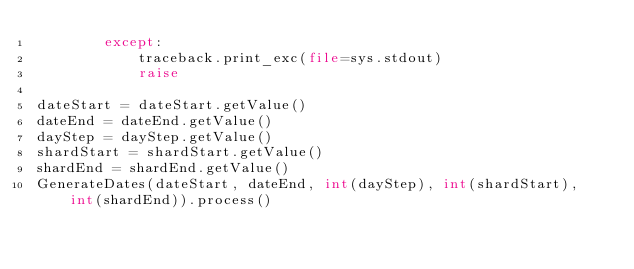Convert code to text. <code><loc_0><loc_0><loc_500><loc_500><_Python_>        except:
            traceback.print_exc(file=sys.stdout)
            raise

dateStart = dateStart.getValue()
dateEnd = dateEnd.getValue()
dayStep = dayStep.getValue()
shardStart = shardStart.getValue()
shardEnd = shardEnd.getValue()
GenerateDates(dateStart, dateEnd, int(dayStep), int(shardStart), int(shardEnd)).process()
</code> 